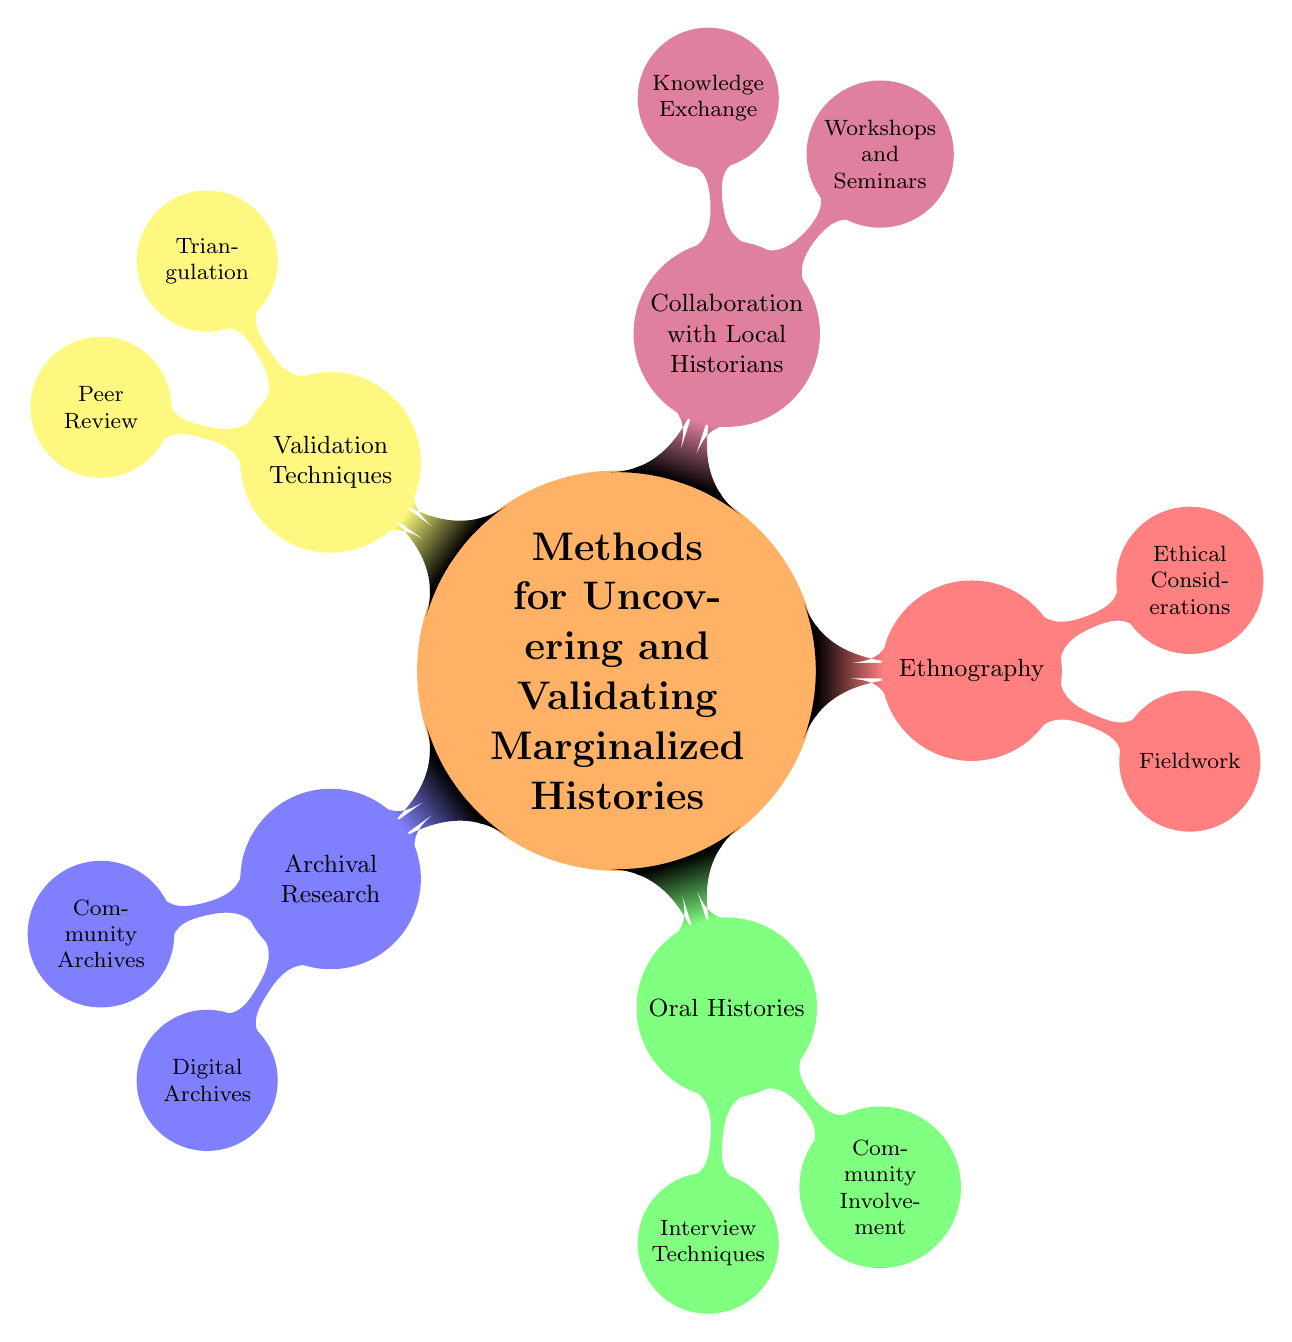What are the primary categories of methods in the diagram? The diagram contains five primary categories: Archival Research, Oral Histories, Ethnography, Collaboration with Local Historians, and Validation Techniques.
Answer: Archival Research, Oral Histories, Ethnography, Collaboration with Local Historians, Validation Techniques How many subcategories are under Ethnography? The Ethnography category has two subcategories: Fieldwork and Ethical Considerations. Counting these subcategories gives us a total of 2.
Answer: 2 What are the examples listed under Community Archives? The examples given under Community Archives in the diagram are Center for Puerto Rican Studies and Lesbian Herstory Archives.
Answer: Center for Puerto Rican Studies, Lesbian Herstory Archives Which category includes Interview Techniques? Interview Techniques are included under the Oral Histories category in the diagram. The relationship shows that it is a subcategory of Oral Histories.
Answer: Oral Histories How are validation techniques organized in the diagram? Validation Techniques are organized into two subcategories: Triangulation and Peer Review. This is indicated by the child nodes stemming from the Validation Techniques node.
Answer: Triangulation, Peer Review What is a key ethical consideration in ethnography? In the diagram, one key ethical consideration listed under Ethnography is Informed Consent. This clearly indicates a significant aspect of ethical research within this method.
Answer: Informed Consent What types of research methods are emphasized in the diagram for uncovering marginalized histories? The diagram emphasizes various methods including archival research, oral histories, ethnography, collaboration with local historians, and validation techniques for uncovering marginalized histories.
Answer: Archival research, oral histories, ethnography, collaboration with local historians, validation techniques What relationship exists between "Workshops and Seminars" and "Collaboration with Local Historians"? Workshops and Seminars are a subcategory of Collaboration with Local Historians, indicating that they fall under this broader category and signify a collaborative approach to local history.
Answer: Collaboration with Local Historians 